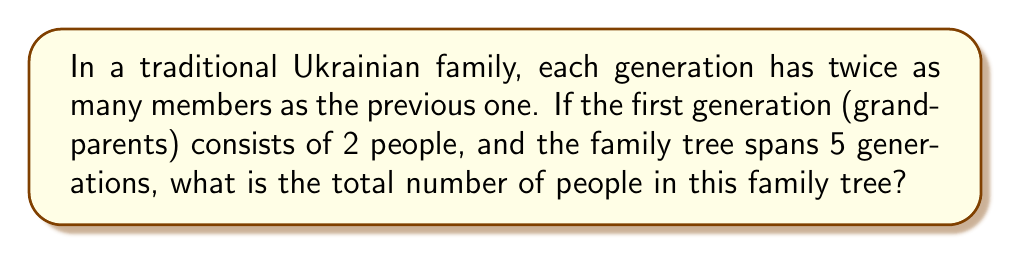Provide a solution to this math problem. Let's approach this step-by-step:

1) We have a geometric sequence where:
   - First term, $a = 2$ (grandparents)
   - Common ratio, $r = 2$ (each generation doubles)
   - Number of terms, $n = 5$ (5 generations)

2) The terms of the sequence are:
   1st generation: $2$
   2nd generation: $2 \cdot 2 = 4$
   3rd generation: $4 \cdot 2 = 8$
   4th generation: $8 \cdot 2 = 16$
   5th generation: $16 \cdot 2 = 32$

3) To find the sum of this geometric sequence, we use the formula:

   $$S_n = \frac{a(1-r^n)}{1-r}$$

   Where $S_n$ is the sum of $n$ terms, $a$ is the first term, and $r$ is the common ratio.

4) Substituting our values:

   $$S_5 = \frac{2(1-2^5)}{1-2}$$

5) Simplify:
   $$S_5 = \frac{2(1-32)}{-1} = \frac{2(-31)}{-1} = 62$$

Therefore, the total number of people in this family tree is 62.
Answer: 62 